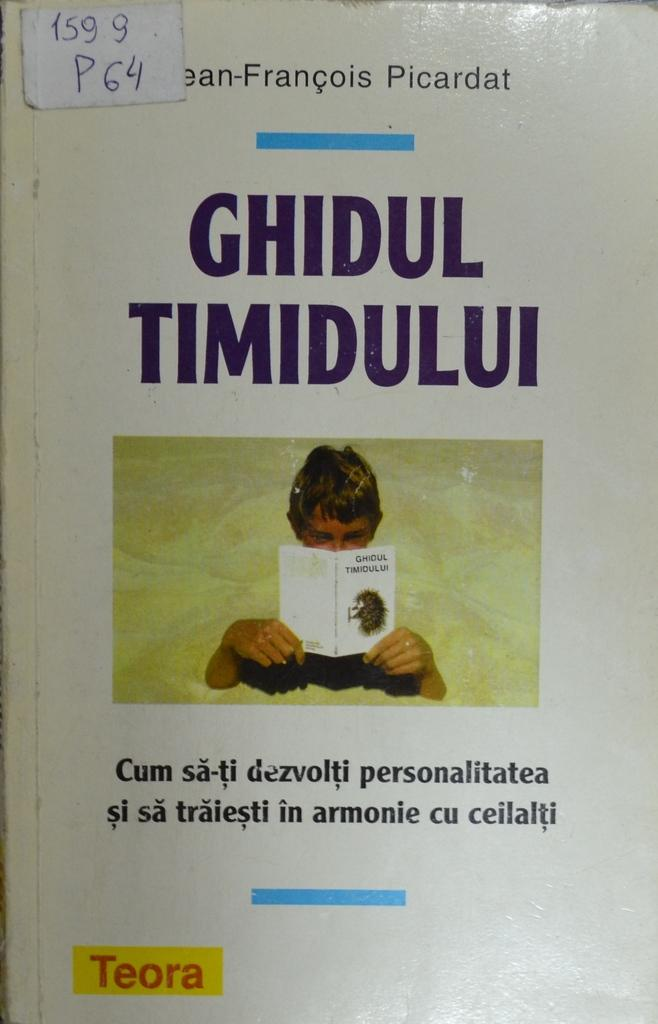Provide a one-sentence caption for the provided image. the cover of book Ghidul Timidului by Picardat. 